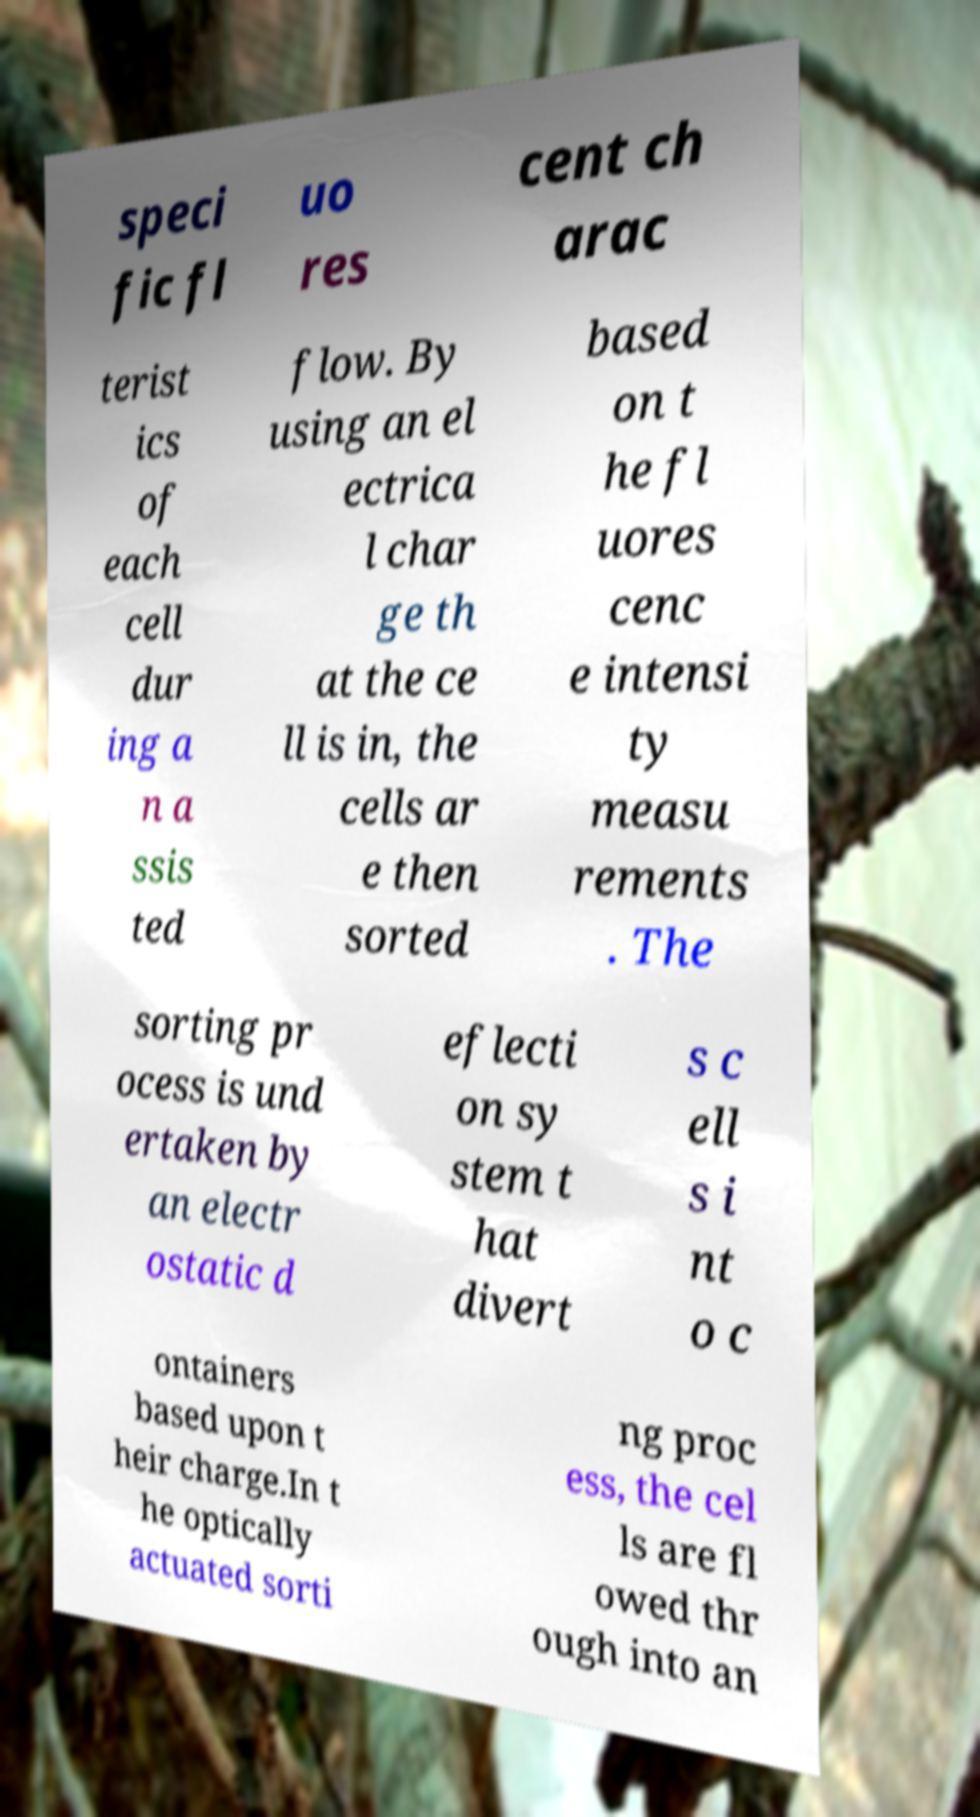Can you read and provide the text displayed in the image?This photo seems to have some interesting text. Can you extract and type it out for me? speci fic fl uo res cent ch arac terist ics of each cell dur ing a n a ssis ted flow. By using an el ectrica l char ge th at the ce ll is in, the cells ar e then sorted based on t he fl uores cenc e intensi ty measu rements . The sorting pr ocess is und ertaken by an electr ostatic d eflecti on sy stem t hat divert s c ell s i nt o c ontainers based upon t heir charge.In t he optically actuated sorti ng proc ess, the cel ls are fl owed thr ough into an 